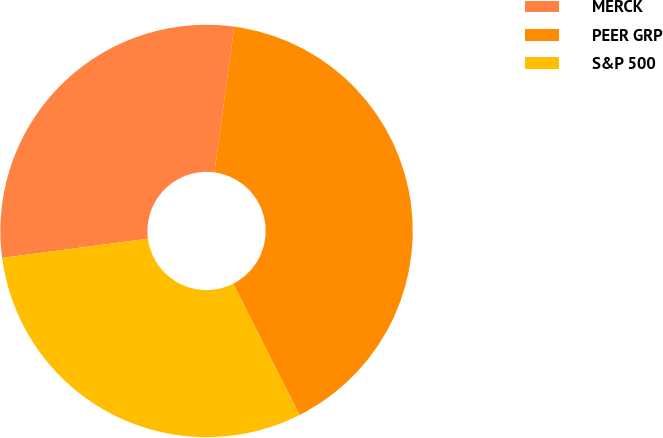Convert chart to OTSL. <chart><loc_0><loc_0><loc_500><loc_500><pie_chart><fcel>MERCK<fcel>PEER GRP<fcel>S&P 500<nl><fcel>29.23%<fcel>40.42%<fcel>30.35%<nl></chart> 